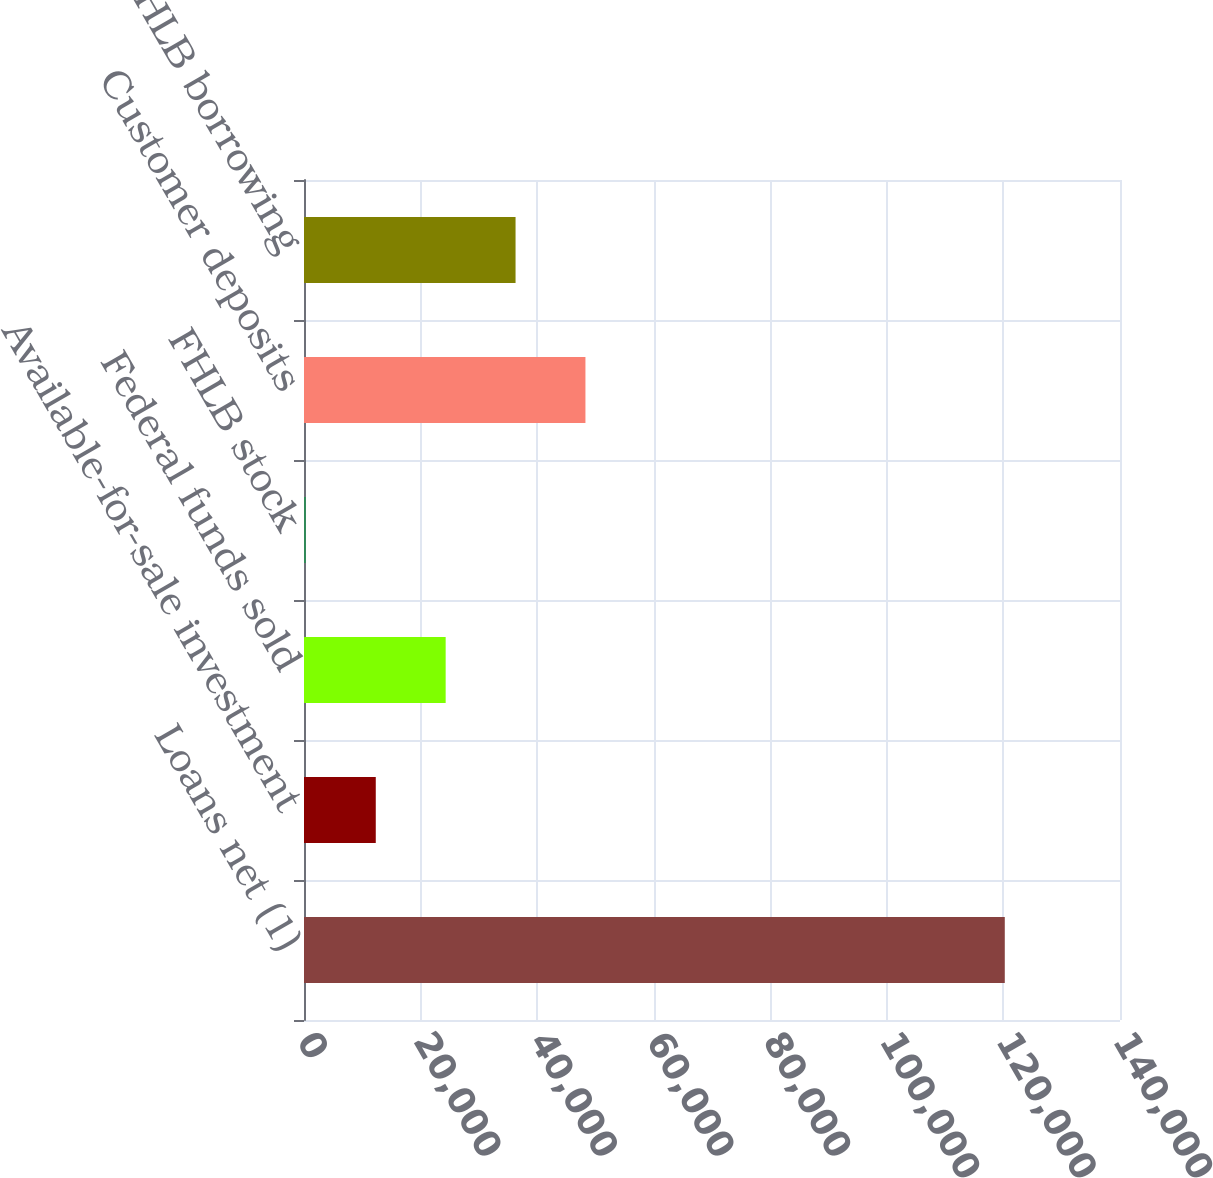Convert chart. <chart><loc_0><loc_0><loc_500><loc_500><bar_chart><fcel>Loans net (1)<fcel>Available-for-sale investment<fcel>Federal funds sold<fcel>FHLB stock<fcel>Customer deposits<fcel>FHLB borrowing<nl><fcel>120233<fcel>12314<fcel>24305<fcel>323<fcel>48287<fcel>36296<nl></chart> 